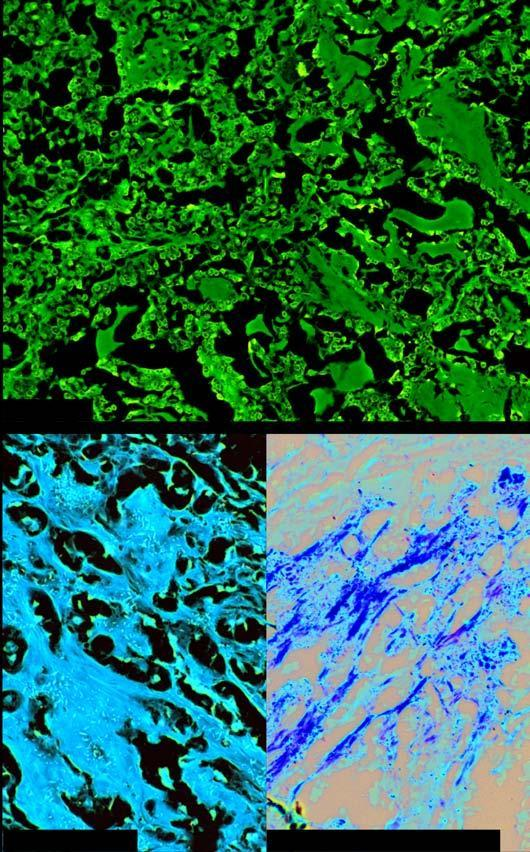what does amyloid show?
Answer the question using a single word or phrase. Congophilia which depicts apple-green birefringence under polarising microscopy 